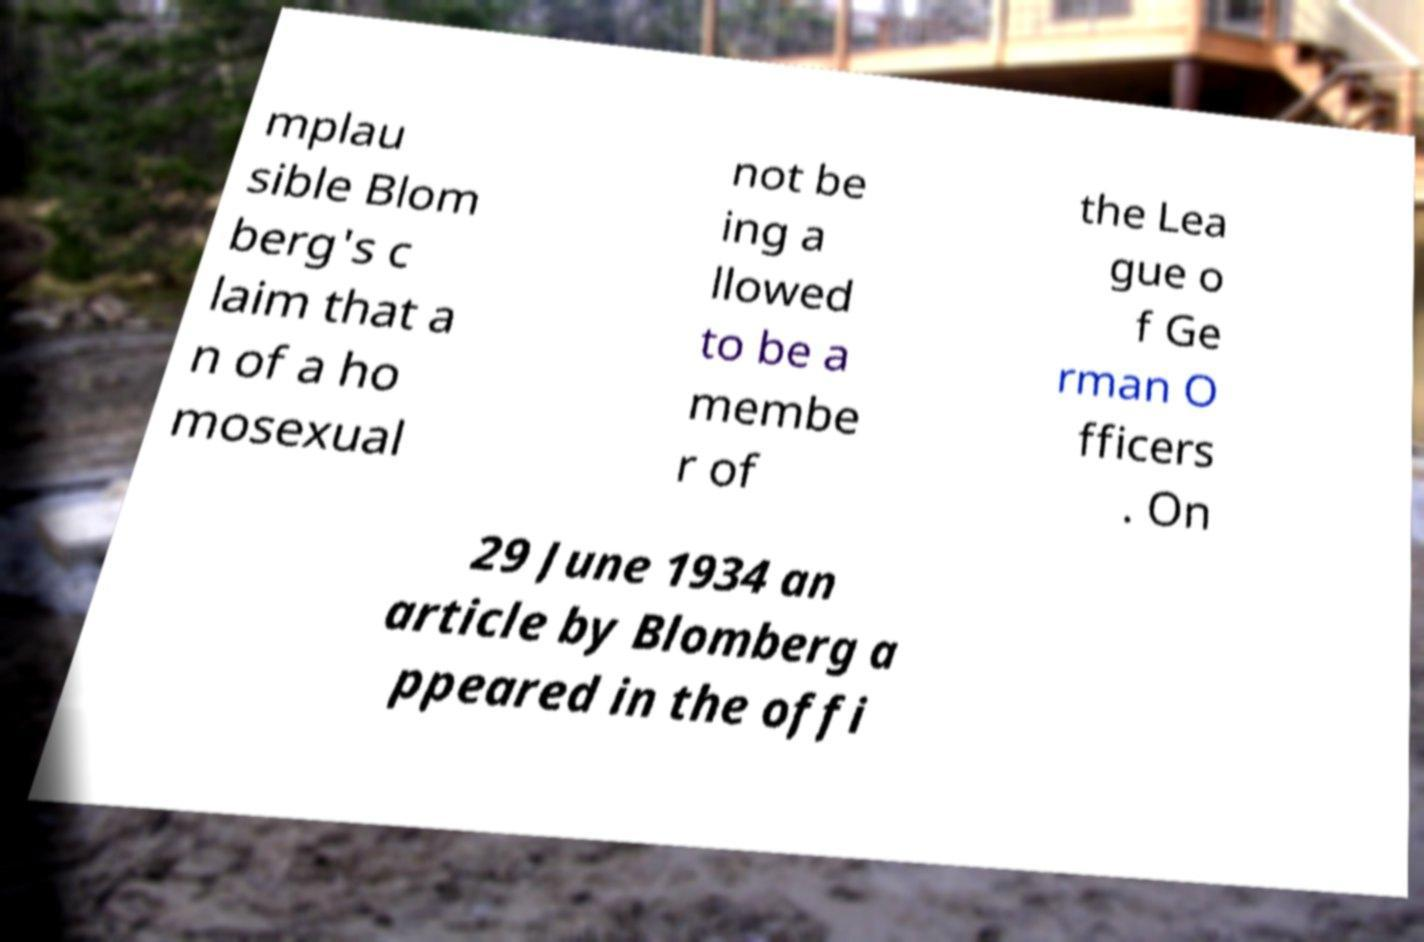I need the written content from this picture converted into text. Can you do that? mplau sible Blom berg's c laim that a n of a ho mosexual not be ing a llowed to be a membe r of the Lea gue o f Ge rman O fficers . On 29 June 1934 an article by Blomberg a ppeared in the offi 